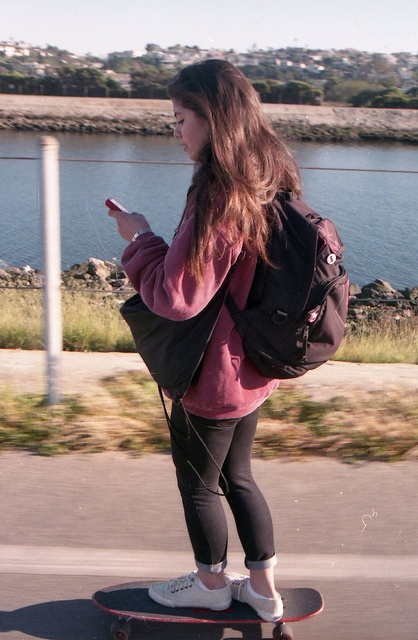Describe the objects in this image and their specific colors. I can see people in white, black, gray, maroon, and brown tones, backpack in white, black, gray, brown, and maroon tones, skateboard in white, black, gray, brown, and maroon tones, handbag in white, black, gray, and purple tones, and cell phone in white, purple, and gray tones in this image. 